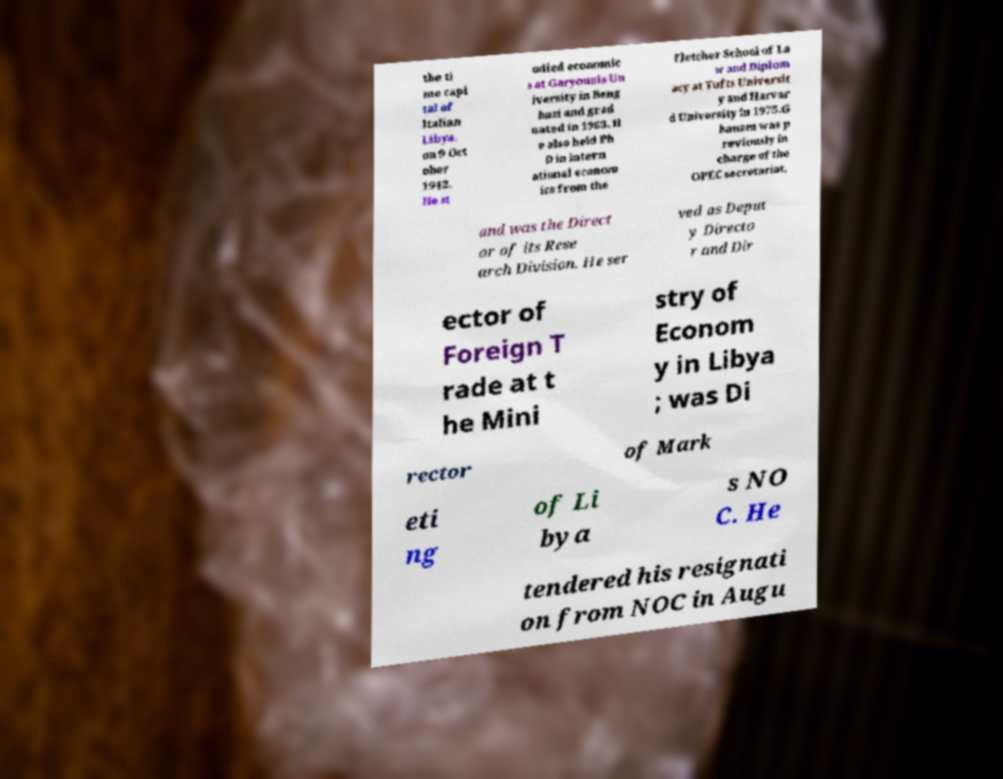Can you accurately transcribe the text from the provided image for me? the ti me capi tal of Italian Libya, on 9 Oct ober 1942. He st udied economic s at Garyounis Un iversity in Beng hazi and grad uated in 1963. H e also held Ph D in intern ational econom ics from the Fletcher School of La w and Diplom acy at Tufts Universit y and Harvar d University in 1975.G hanem was p reviously in charge of the OPEC secretariat, and was the Direct or of its Rese arch Division. He ser ved as Deput y Directo r and Dir ector of Foreign T rade at t he Mini stry of Econom y in Libya ; was Di rector of Mark eti ng of Li bya s NO C. He tendered his resignati on from NOC in Augu 